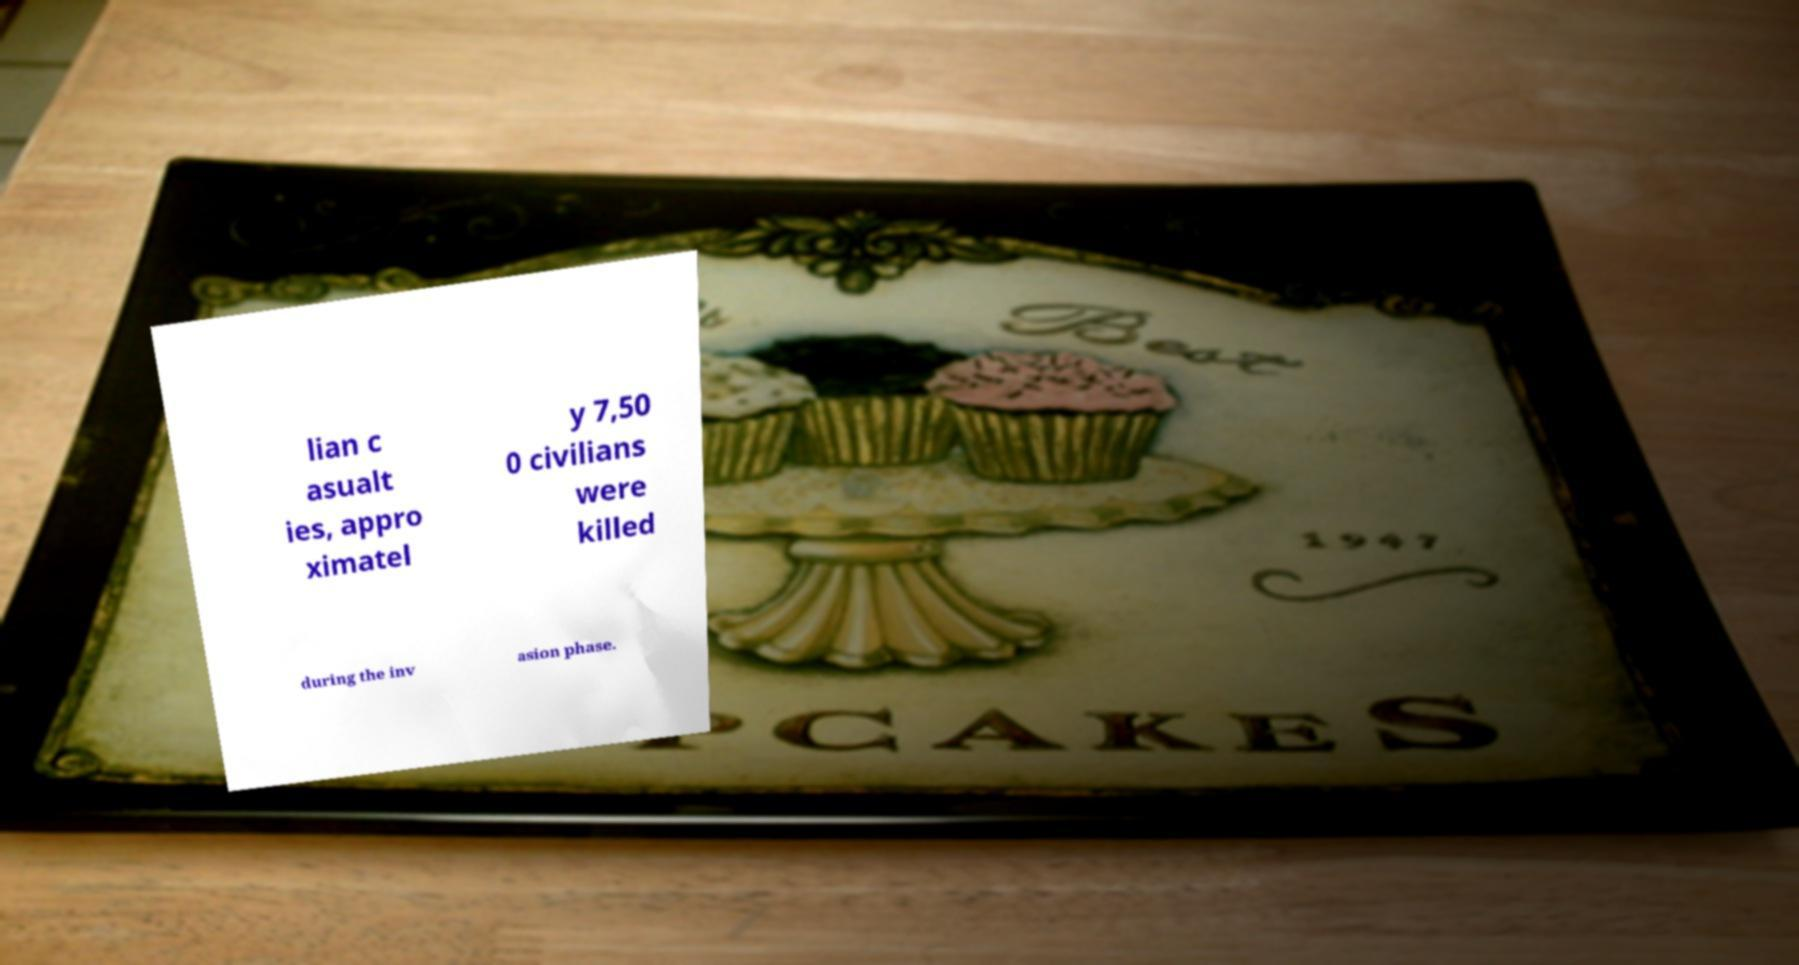There's text embedded in this image that I need extracted. Can you transcribe it verbatim? lian c asualt ies, appro ximatel y 7,50 0 civilians were killed during the inv asion phase. 